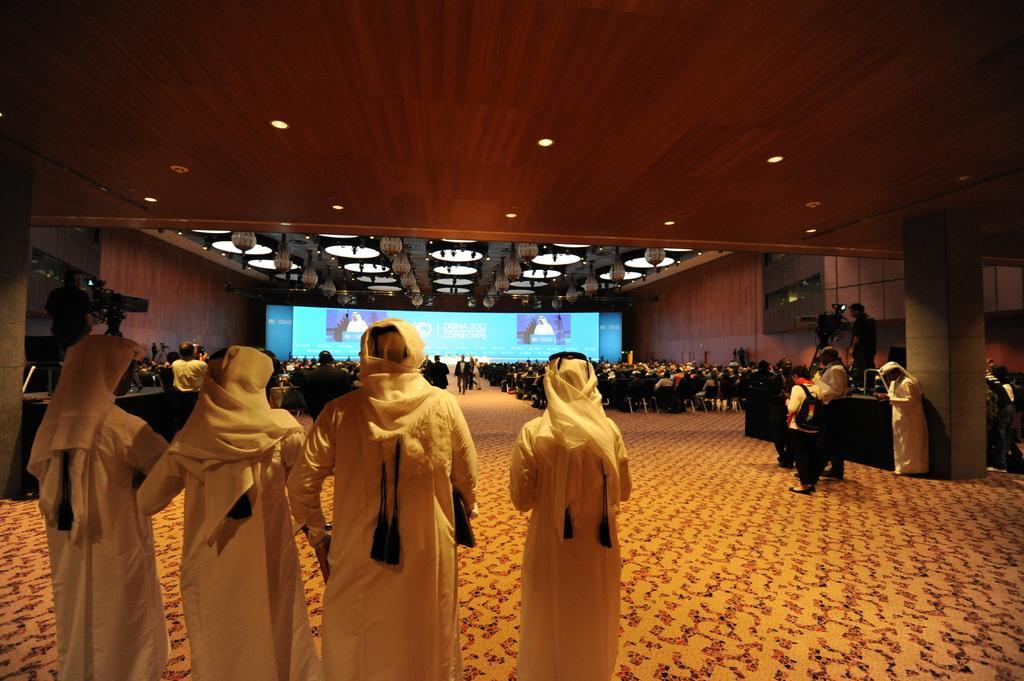In one or two sentences, can you explain what this image depicts? In this image there are people standing in the foreground. Many people sitting on chairs in the background. There is a big screen. There are tables and cameras on both the sides. There is carpet. There are lights at the top. 